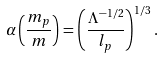Convert formula to latex. <formula><loc_0><loc_0><loc_500><loc_500>\alpha \left ( \frac { m _ { p } } { m } \right ) = \left ( \frac { \Lambda ^ { - 1 / 2 } } { l _ { p } } \right ) ^ { 1 / 3 } .</formula> 